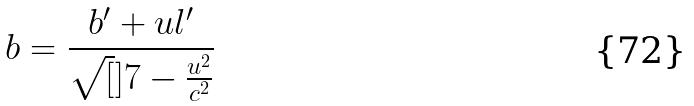Convert formula to latex. <formula><loc_0><loc_0><loc_500><loc_500>b = \frac { b ^ { \prime } + u l ^ { \prime } } { \sqrt { [ } ] { 7 - \frac { u ^ { 2 } } { c ^ { 2 } } } }</formula> 